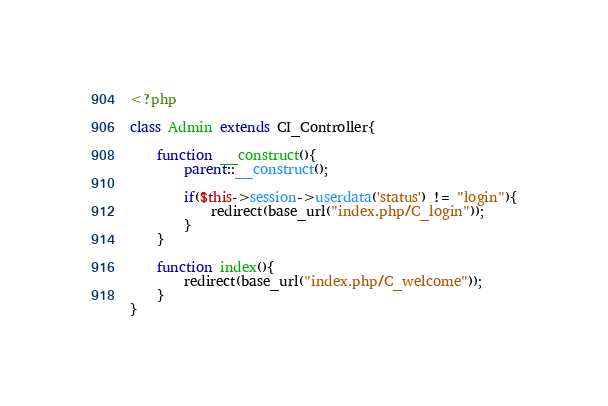<code> <loc_0><loc_0><loc_500><loc_500><_PHP_><?php 

class Admin extends CI_Controller{

	function __construct(){
		parent::__construct();
	
		if($this->session->userdata('status') != "login"){
			redirect(base_url("index.php/C_login"));
		}
	}

	function index(){
		redirect(base_url("index.php/C_welcome"));
	}
}</code> 